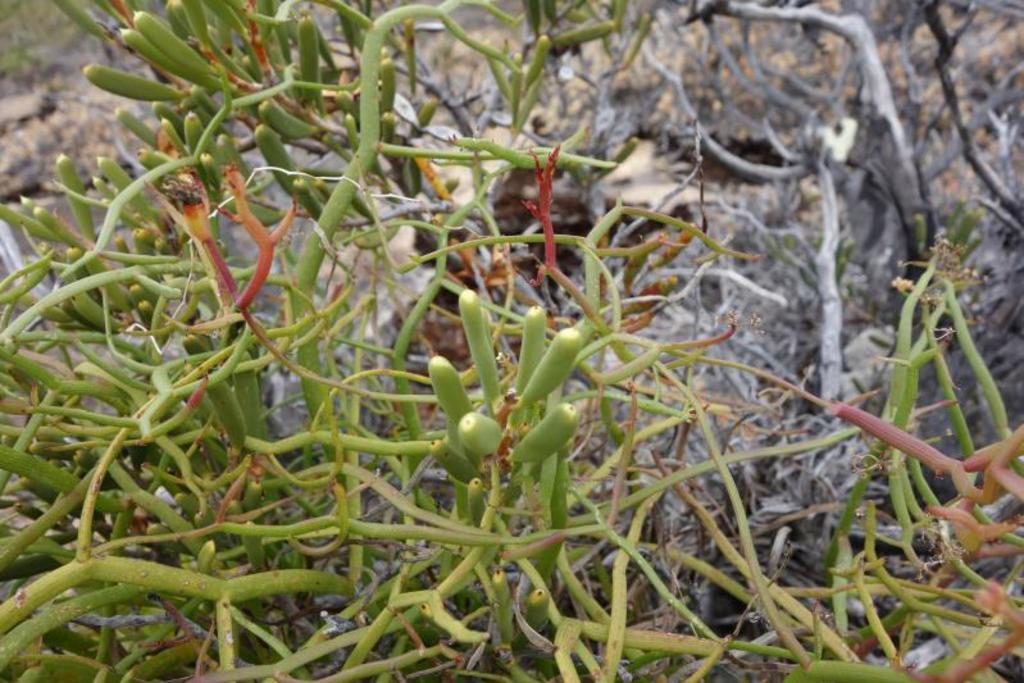What type of vegetation is present in the image? There are bushes in the image. What caption is written on the stocking of the writer in the image? There is no writer, stocking, or caption present in the image; it only features bushes. 